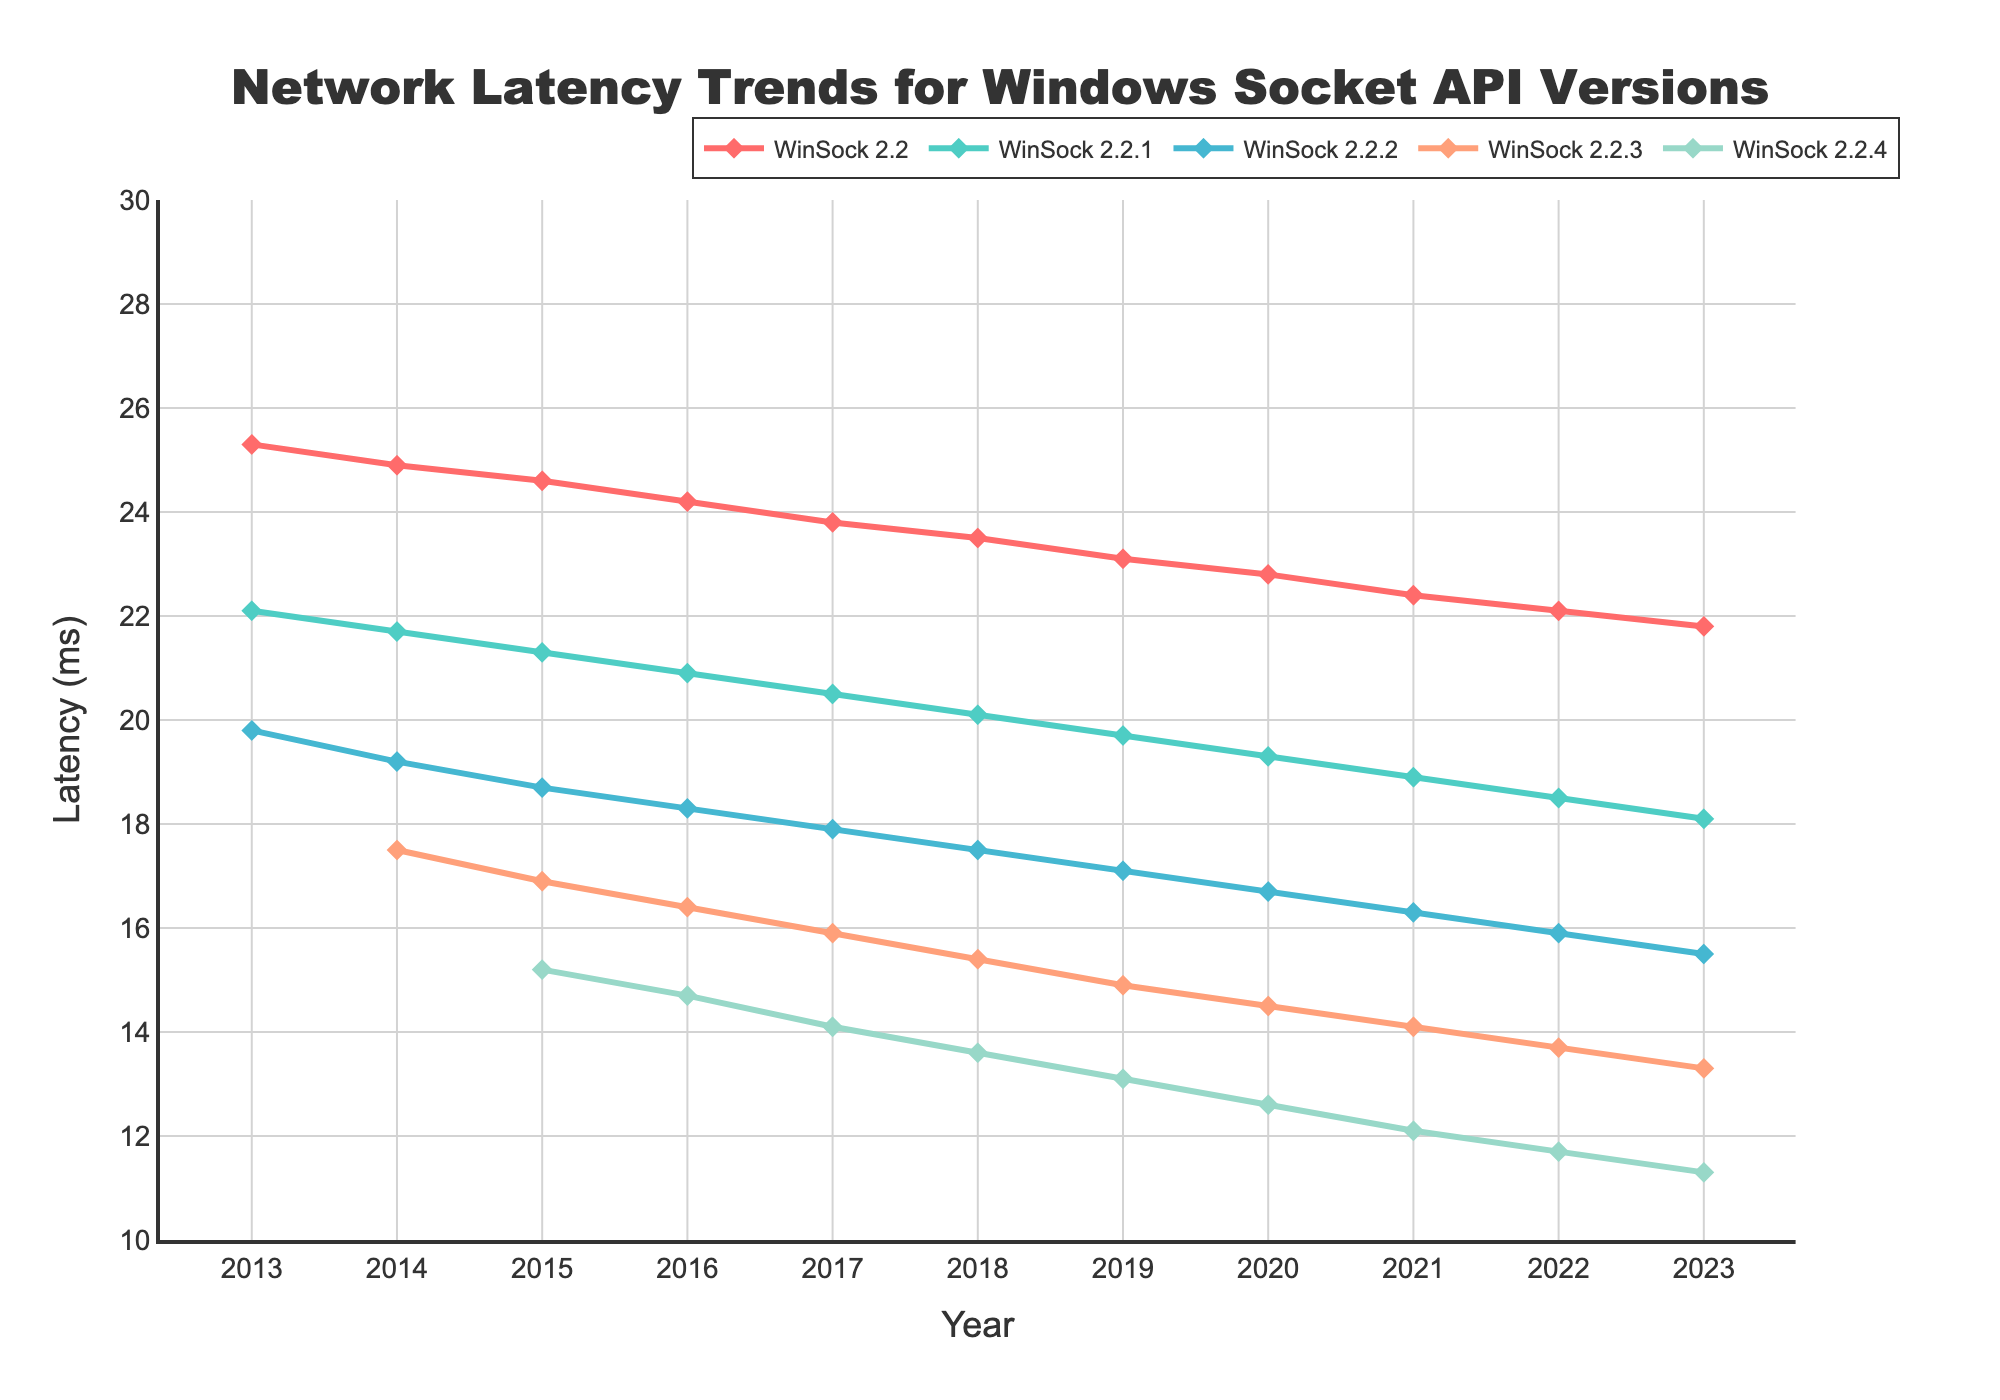What is the trend of WinSock 2.2's network latency from 2013 to 2023? Observe the line for WinSock 2.2, which shows a consistent decrease in network latency over the years from 2013 to 2023.
Answer: Decreasing In which year did WinSock 2.2.4 reach its lowest latency? Locate the lowest point on the line for WinSock 2.2.4 and refer to the x-axis to identify the corresponding year. This point is at the end of the line in 2023.
Answer: 2023 Which WinSock version has the lowest latency in 2023? Compare the endpoints of all lines for the year 2023 on the x-axis. The lowest point is for WinSock 2.2.4 version.
Answer: WinSock 2.2.4 How much did the latency for WinSock 2.2 decrease from 2013 to 2023? Subtract the latency value of WinSock 2.2 in 2023 from its latency value in 2013 (25.3 - 21.8).
Answer: 3.5 ms Which year has the highest latency for any version of WinSock? Look at all the starting points of the lines (2013) where the latency values are the highest, and identify the highest value among them, which is for WinSock 2.2.
Answer: 2013 What is the latency difference between WinSock 2.2.1 and WinSock 2.2.2 in 2013? Subtract the latency of WinSock 2.2.2 from the latency of WinSock 2.2.1 in 2013 (22.1 - 19.8).
Answer: 2.3 ms What is the average latency for WinSock 2.2.3 over the years it existed? Sum the latency values of WinSock 2.2.3 from 2014 to 2023 and divide by the number of years (10). Average = (17.5 + 16.9 + 16.4 + 15.9 + 15.4 + 14.9 + 14.5 + 14.1 + 13.7 + 13.3) / 10 = 15.26 ms
Answer: 15.26 ms Which two versions have the closest latencies in 2017? Compare the latencies of all versions in 2017 and identify the two versions with the smallest difference. WinSock 2.2.2 (17.9 ms) and WinSock 2.2.3 (15.9 ms) have the smallest difference of 2 ms.
Answer: WinSock 2.2.3 and WinSock 2.2.2 By what percentage did the latency of WinSock 2.2.1 decrease from 2017 to 2018? Calculate the percentage decrease using the formula: ((Old value - New value) / Old value) * 100. For 2017 to 2018 (20.5 - 20.1) / 20.5 * 100 = 1.95%.
Answer: 1.95% Which WinSock version had the fastest rate of latency improvement between 2016 and 2020? Calculate the change in latency for each version between 2016 and 2020 and determine the version with the highest decrease. WinSock 2.2.4: 14.7 - 12.6 = 2.1 ms improvement in 4 years.
Answer: WinSock 2.2.4 